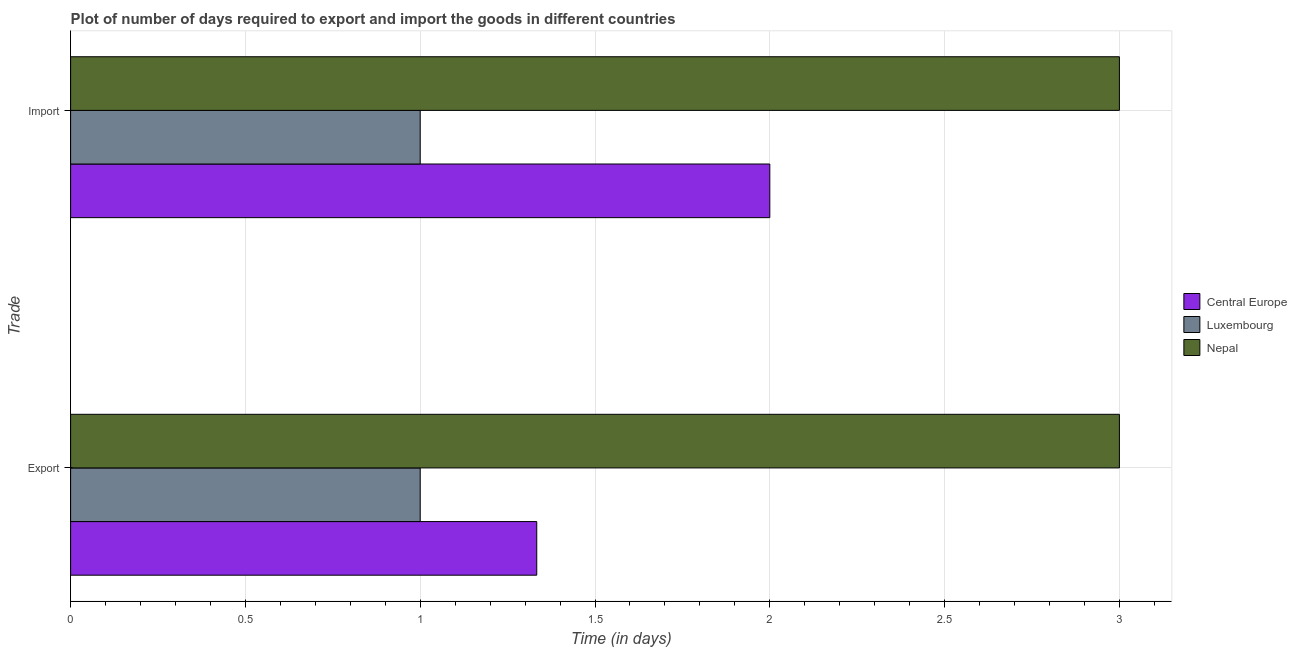How many different coloured bars are there?
Provide a short and direct response. 3. How many groups of bars are there?
Make the answer very short. 2. Are the number of bars on each tick of the Y-axis equal?
Your response must be concise. Yes. How many bars are there on the 1st tick from the top?
Offer a very short reply. 3. What is the label of the 2nd group of bars from the top?
Offer a terse response. Export. What is the time required to import in Central Europe?
Your answer should be very brief. 2. In which country was the time required to export maximum?
Offer a terse response. Nepal. In which country was the time required to import minimum?
Your response must be concise. Luxembourg. What is the total time required to export in the graph?
Give a very brief answer. 5.33. What is the difference between the time required to export in Nepal and that in Luxembourg?
Give a very brief answer. 2. What is the difference between the time required to export in Nepal and the time required to import in Central Europe?
Keep it short and to the point. 1. What is the average time required to export per country?
Offer a very short reply. 1.78. In how many countries, is the time required to export greater than 2.9 days?
Give a very brief answer. 1. What is the ratio of the time required to export in Luxembourg to that in Nepal?
Give a very brief answer. 0.33. Is the time required to import in Luxembourg less than that in Central Europe?
Ensure brevity in your answer.  Yes. In how many countries, is the time required to import greater than the average time required to import taken over all countries?
Your response must be concise. 1. What does the 2nd bar from the top in Export represents?
Give a very brief answer. Luxembourg. What does the 1st bar from the bottom in Import represents?
Provide a short and direct response. Central Europe. Are all the bars in the graph horizontal?
Ensure brevity in your answer.  Yes. How many countries are there in the graph?
Offer a very short reply. 3. Are the values on the major ticks of X-axis written in scientific E-notation?
Your response must be concise. No. Does the graph contain any zero values?
Your response must be concise. No. Does the graph contain grids?
Offer a very short reply. Yes. How many legend labels are there?
Provide a succinct answer. 3. What is the title of the graph?
Offer a terse response. Plot of number of days required to export and import the goods in different countries. Does "Myanmar" appear as one of the legend labels in the graph?
Keep it short and to the point. No. What is the label or title of the X-axis?
Keep it short and to the point. Time (in days). What is the label or title of the Y-axis?
Offer a very short reply. Trade. What is the Time (in days) of Central Europe in Export?
Give a very brief answer. 1.33. What is the Time (in days) of Luxembourg in Export?
Your response must be concise. 1. What is the Time (in days) in Nepal in Export?
Give a very brief answer. 3. What is the Time (in days) of Nepal in Import?
Your response must be concise. 3. Across all Trade, what is the maximum Time (in days) of Central Europe?
Offer a terse response. 2. Across all Trade, what is the maximum Time (in days) in Luxembourg?
Your answer should be compact. 1. Across all Trade, what is the minimum Time (in days) in Central Europe?
Offer a terse response. 1.33. Across all Trade, what is the minimum Time (in days) of Luxembourg?
Provide a succinct answer. 1. What is the difference between the Time (in days) of Central Europe in Export and that in Import?
Your answer should be compact. -0.67. What is the difference between the Time (in days) of Luxembourg in Export and that in Import?
Offer a terse response. 0. What is the difference between the Time (in days) of Central Europe in Export and the Time (in days) of Nepal in Import?
Make the answer very short. -1.67. What is the difference between the Time (in days) of Luxembourg in Export and the Time (in days) of Nepal in Import?
Offer a terse response. -2. What is the average Time (in days) in Central Europe per Trade?
Offer a very short reply. 1.67. What is the average Time (in days) in Luxembourg per Trade?
Your answer should be very brief. 1. What is the average Time (in days) of Nepal per Trade?
Keep it short and to the point. 3. What is the difference between the Time (in days) of Central Europe and Time (in days) of Nepal in Export?
Make the answer very short. -1.67. What is the difference between the Time (in days) in Central Europe and Time (in days) in Luxembourg in Import?
Make the answer very short. 1. What is the difference between the Time (in days) in Central Europe and Time (in days) in Nepal in Import?
Your answer should be compact. -1. What is the ratio of the Time (in days) in Nepal in Export to that in Import?
Your response must be concise. 1. What is the difference between the highest and the lowest Time (in days) of Luxembourg?
Your answer should be compact. 0. What is the difference between the highest and the lowest Time (in days) in Nepal?
Give a very brief answer. 0. 